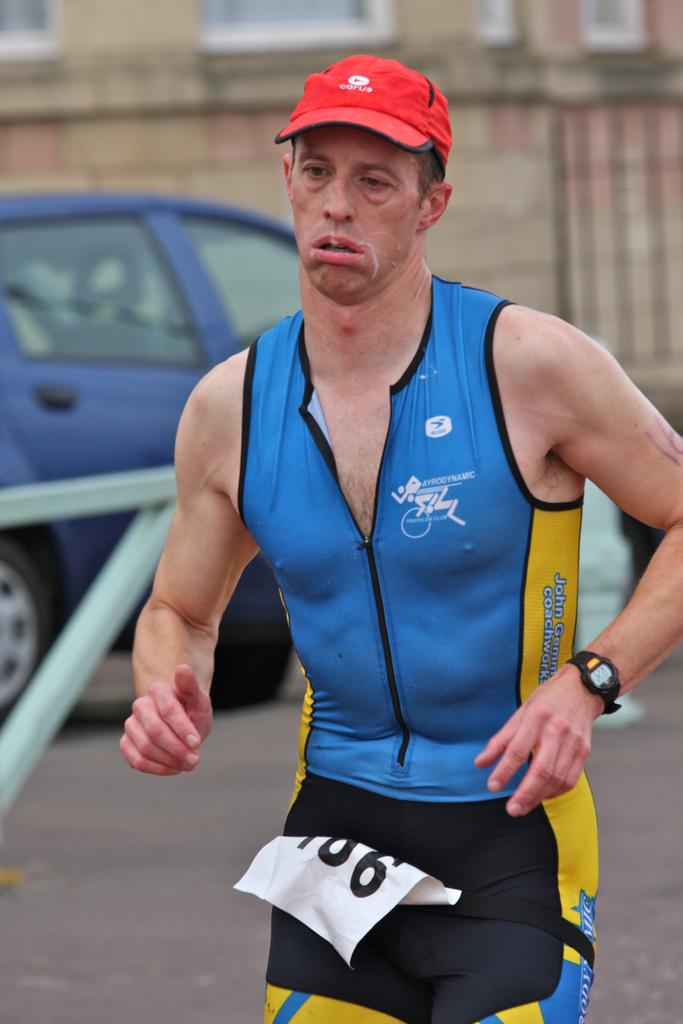Provide a one-sentence caption for the provided image. A man in a red cap and a blue and yellow running outfit and the number 106 printed on a paper on his person. 